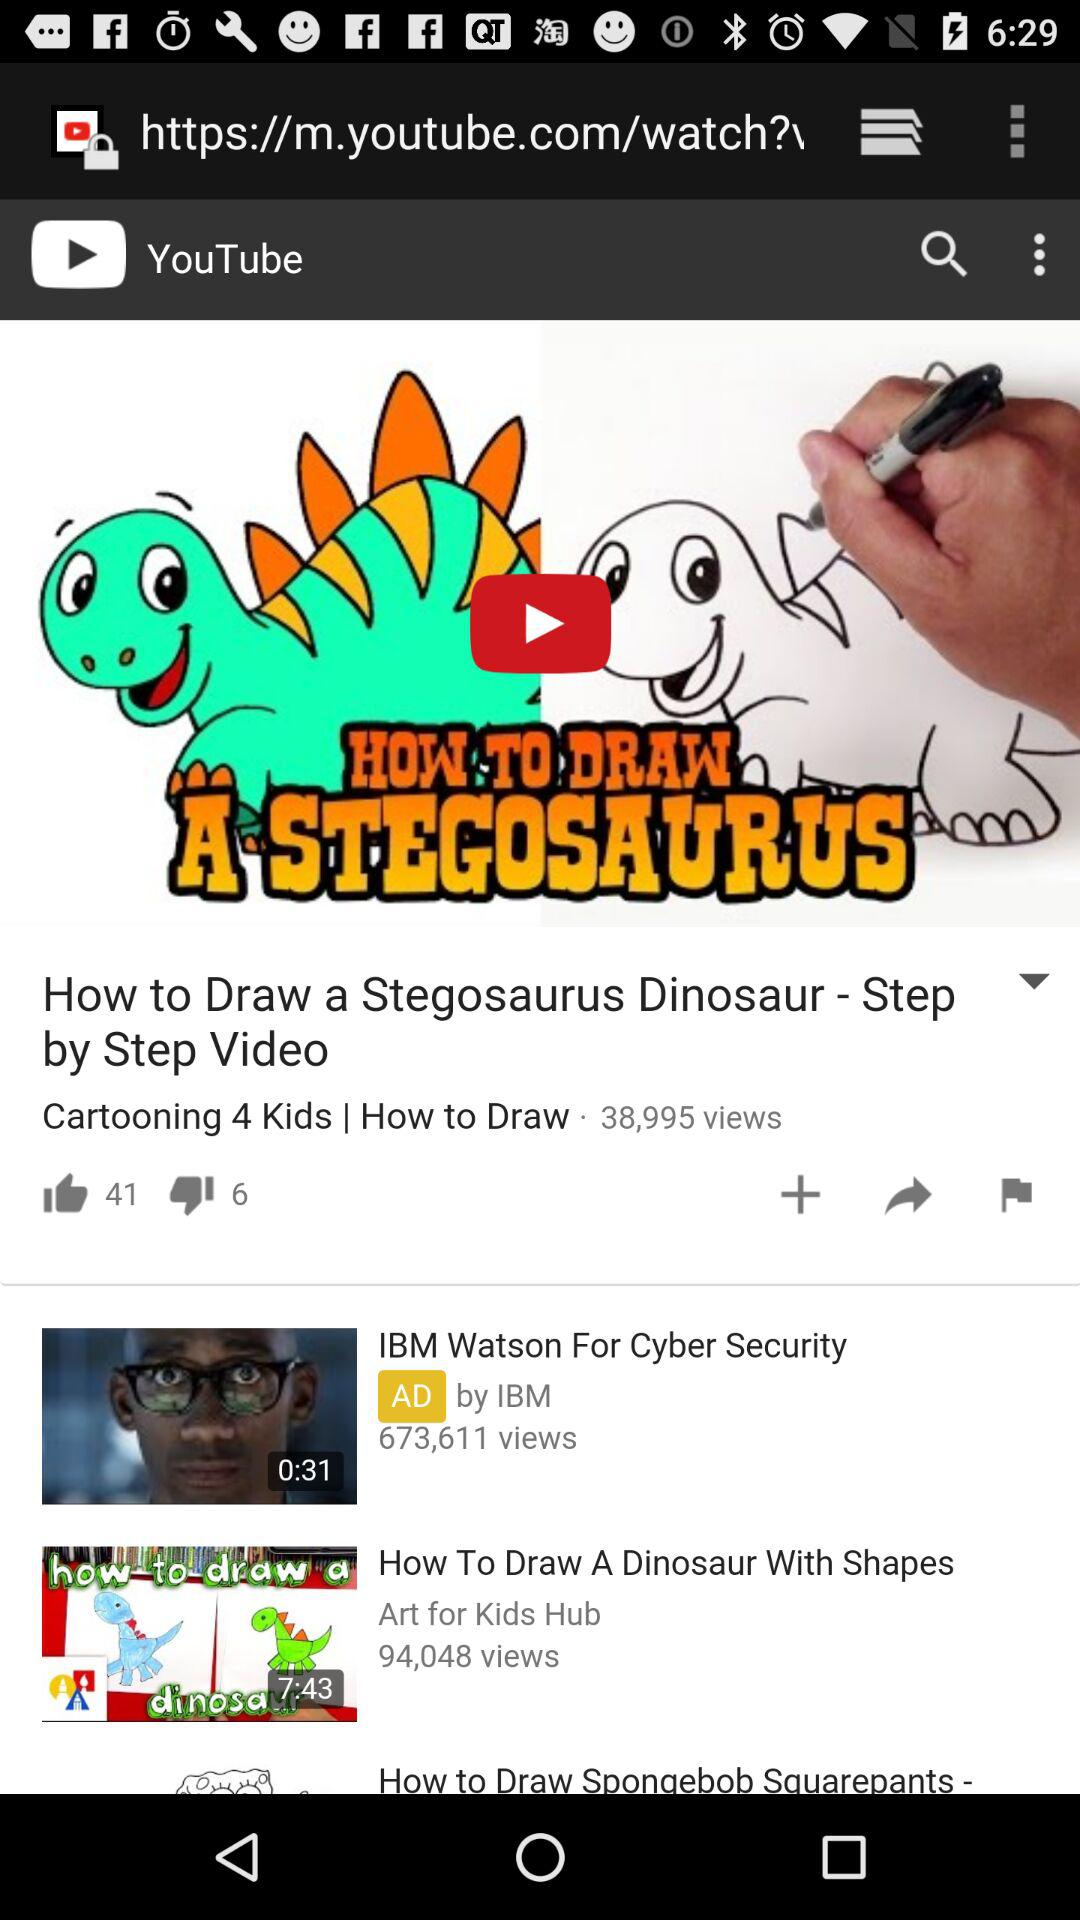What is the number of views on the video "How to Draw a Stegosaurus Dinosaur - Step by Step Video"? The number of views on the video "How to Draw a Stegosaurus Dinosaur - Step by Step Video" is 38,995. 